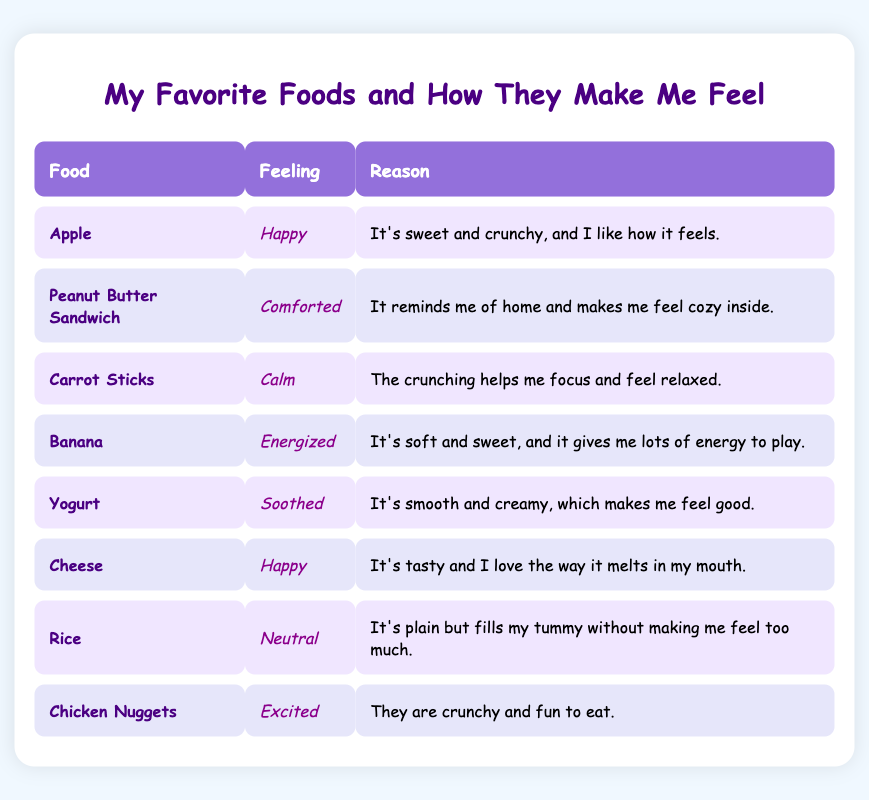What food makes you feel excited? The table shows that Chicken Nuggets make someone feel excited. We can look in the "Feeling" column and see that next to Chicken Nuggets, the feeling is noted as "Excited."
Answer: Chicken Nuggets Which food makes you feel calm? In the table, the food that makes someone feel calm is Carrot Sticks. The "Feeling" column next to Carrot Sticks shows "Calm."
Answer: Carrot Sticks Are there two foods that make you feel happy? Yes, both Apple and Cheese make someone feel happy. We can see that in the "Feeling" column, both are labeled with "Happy."
Answer: Yes What is the reason you feel energized when you eat a banana? The reason given for feeling energized when eating a banana is that it is soft and sweet, and it gives lots of energy to play. This is found in the "Reason" column next to Banana.
Answer: It's soft and sweet, and it gives me lots of energy to play Which food has a neutral feeling associated with it? Rice is associated with a neutral feeling, as shown in the "Feeling" column next to Rice where it says "Neutral."
Answer: Rice How many foods make you feel happy or excited? There are three foods: two that make you feel happy (Apple and Cheese) and one that makes you feel excited (Chicken Nuggets). So, adding them together gives a total of 3.
Answer: 3 Does yogurt make you feel happy? No, yogurt does not make you feel happy. The table indicates that yogurt makes someone feel "Soothed," which is different than happy.
Answer: No What is the common feeling for Apple and Cheese? Both Apple and Cheese have the feeling "Happy." We can look in the "Feeling" column and see both have "Happy" listed next to them.
Answer: Happy 